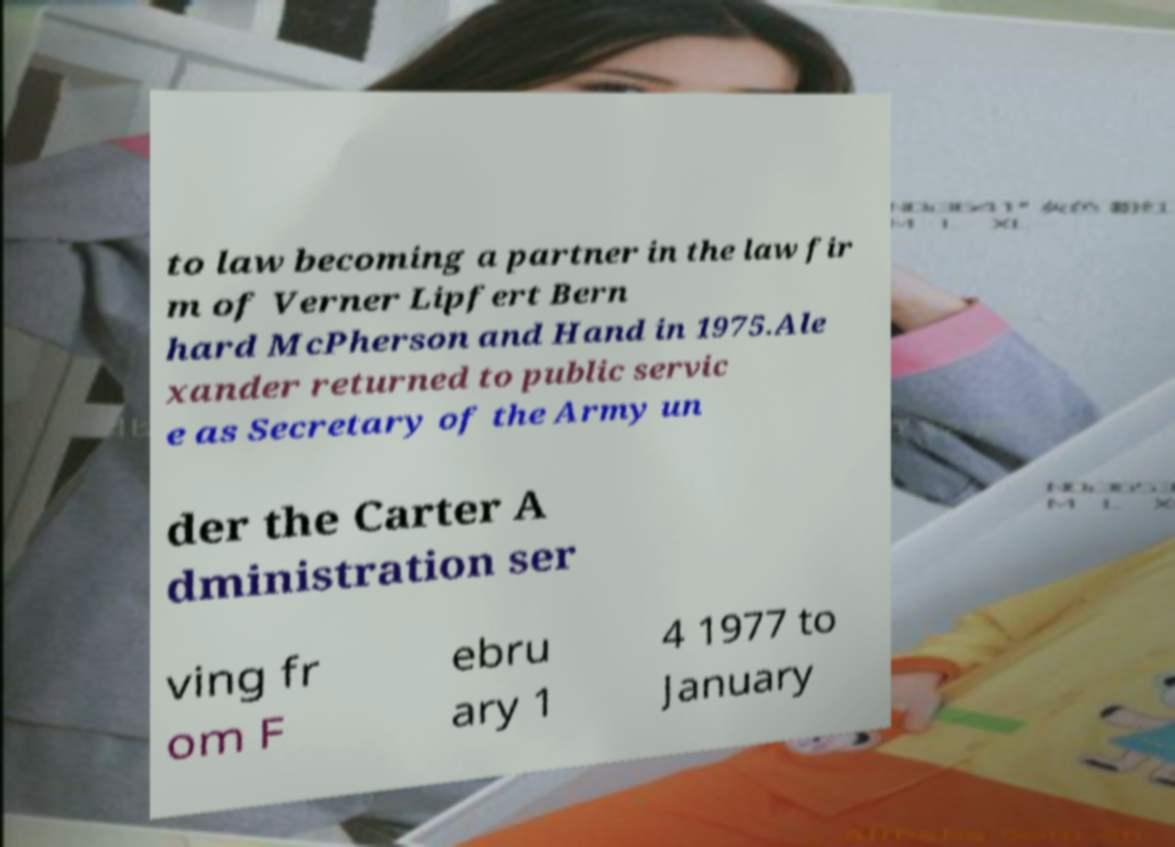There's text embedded in this image that I need extracted. Can you transcribe it verbatim? to law becoming a partner in the law fir m of Verner Lipfert Bern hard McPherson and Hand in 1975.Ale xander returned to public servic e as Secretary of the Army un der the Carter A dministration ser ving fr om F ebru ary 1 4 1977 to January 